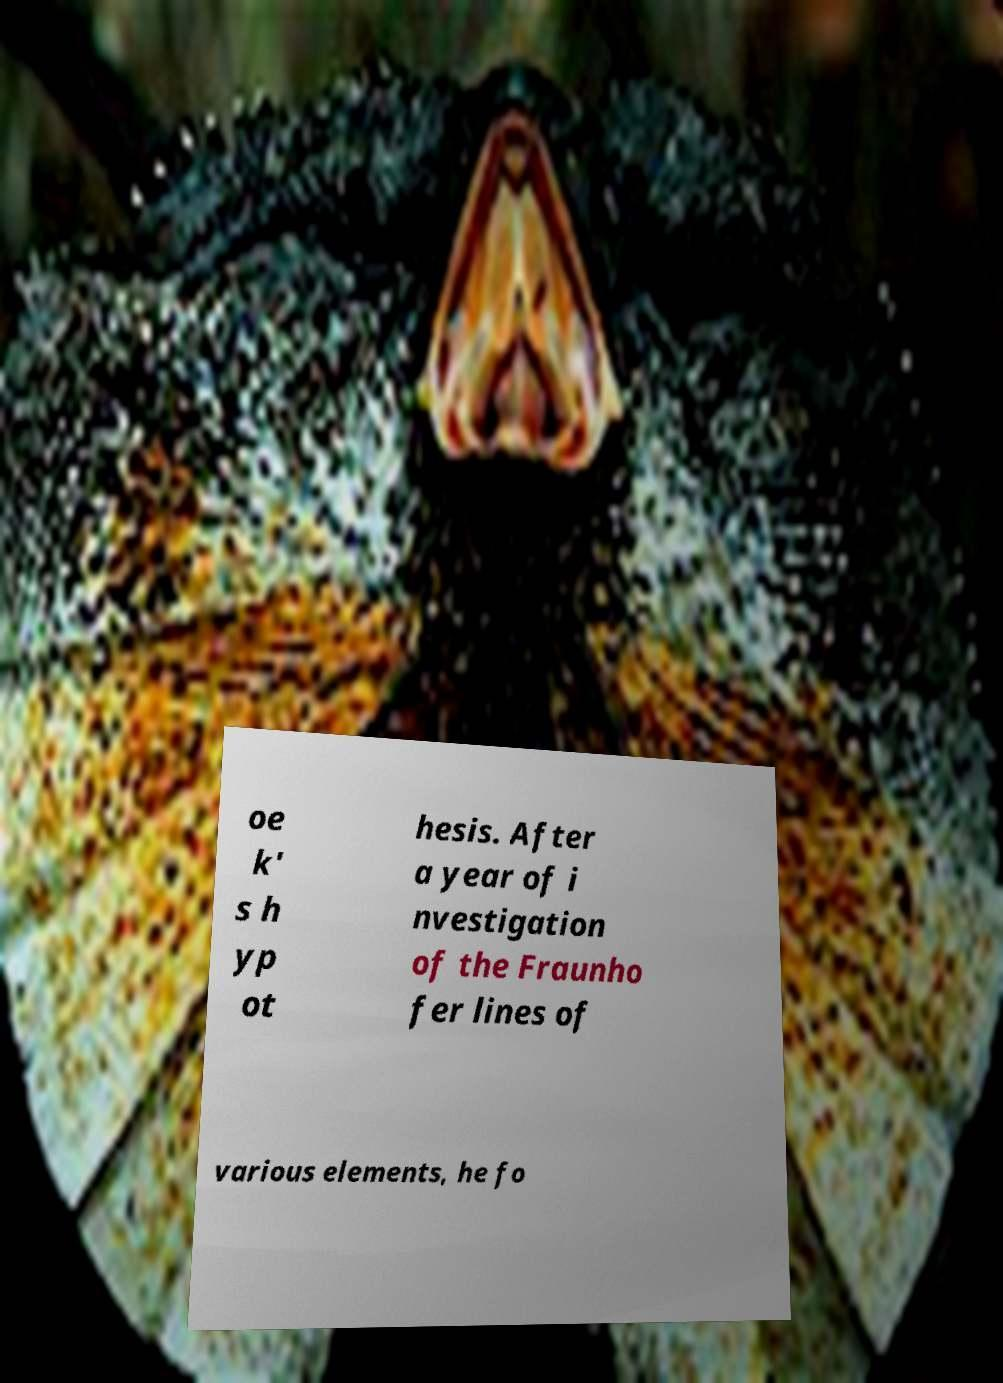Can you accurately transcribe the text from the provided image for me? oe k' s h yp ot hesis. After a year of i nvestigation of the Fraunho fer lines of various elements, he fo 